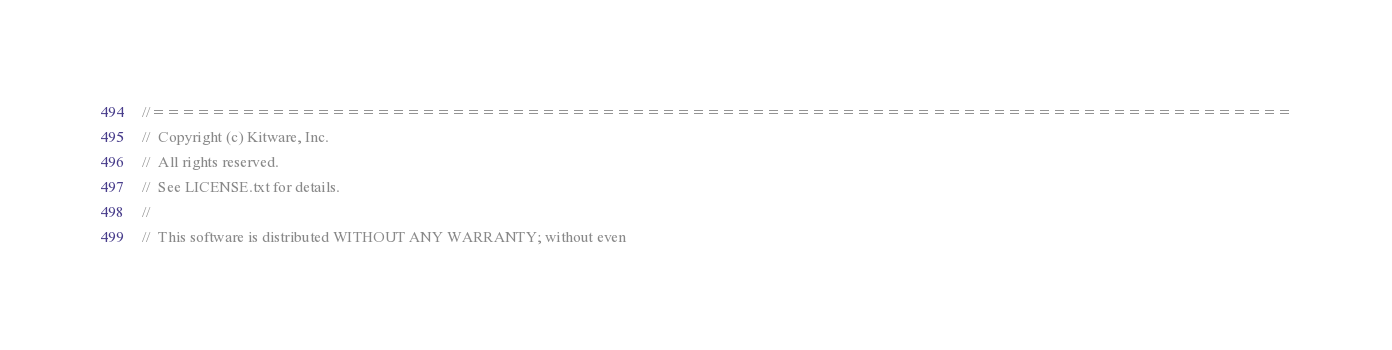Convert code to text. <code><loc_0><loc_0><loc_500><loc_500><_C++_>//============================================================================
//  Copyright (c) Kitware, Inc.
//  All rights reserved.
//  See LICENSE.txt for details.
//
//  This software is distributed WITHOUT ANY WARRANTY; without even</code> 